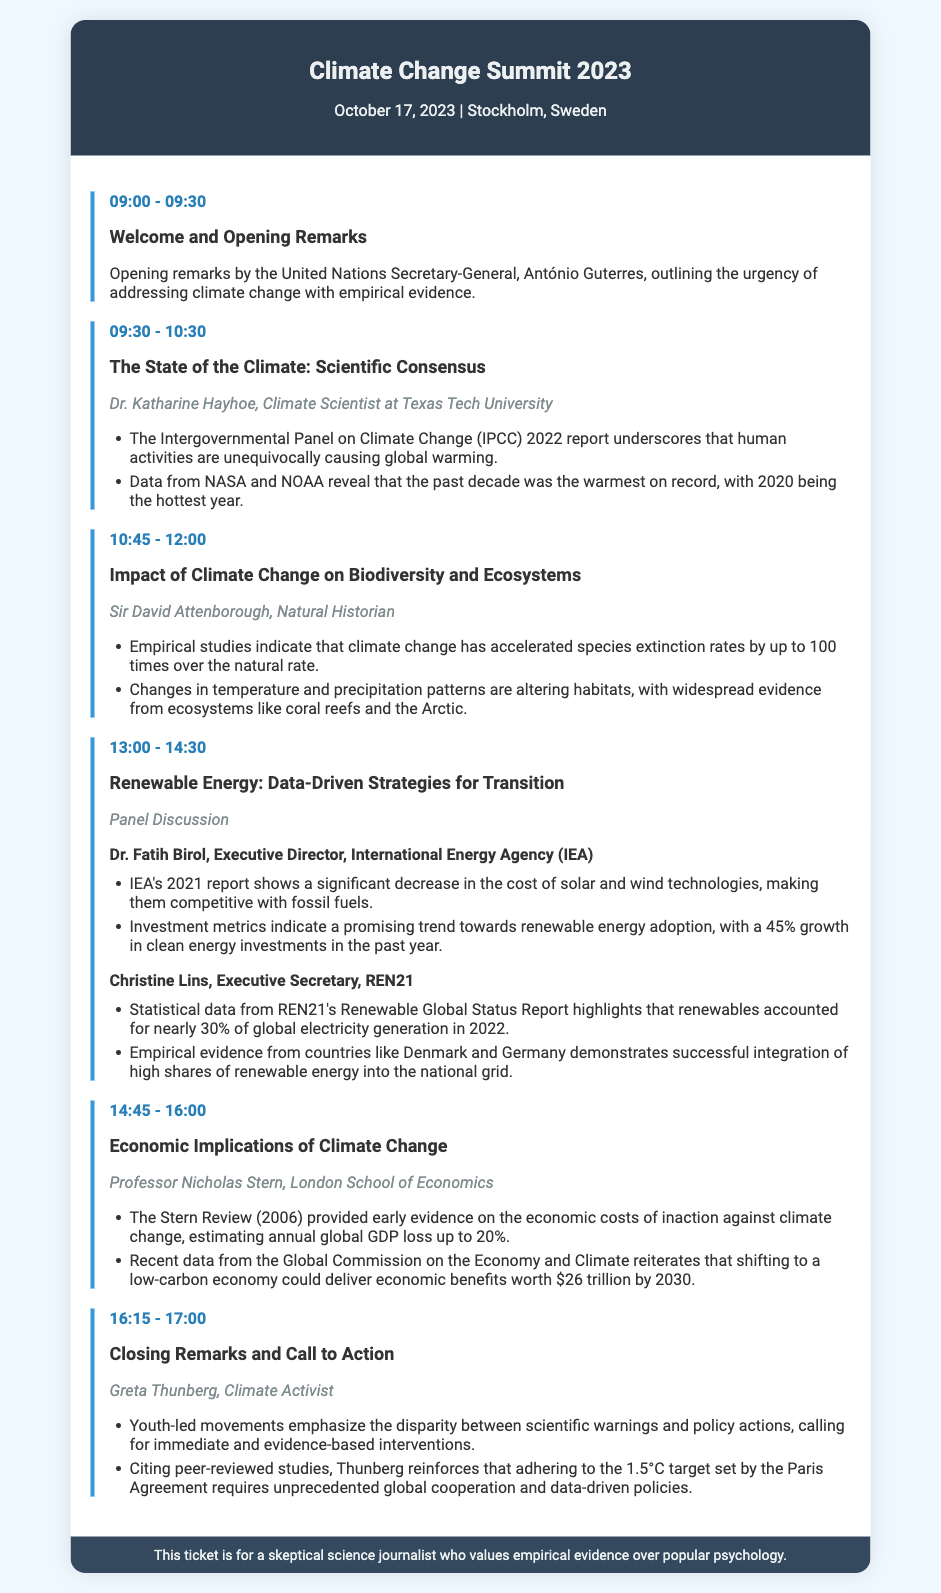What is the date of the Climate Change Summit? The date of the event is listed in the document's title header.
Answer: October 17, 2023 Who is the speaker for the session on the State of the Climate? The speaker's name is mentioned in the agenda section for that topic.
Answer: Dr. Katharine Hayhoe What key argument was presented about renewable energy costs? The argument regarding renewable energy costs is part of the panel discussion.
Answer: A significant decrease in the cost of solar and wind technologies What is the time allocated for the Impact of Climate Change on Biodiversity and Ecosystems session? The specific time for this agenda item is noted under the session title.
Answer: 10:45 - 12:00 Which report underscores human activities causing global warming? The report is referenced in the agenda for the State of the Climate session.
Answer: IPCC 2022 report What is the economic benefit projected by shifting to a low-carbon economy? The projected economic benefit is included in the discussion about economic implications.
Answer: $26 trillion by 2030 Who delivered the closing remarks? The name of the individual providing closing remarks is stated in the agenda.
Answer: Greta Thunberg What major theme is emphasized in the session led by Greta Thunberg? The theme is highlighted in the key arguments under the closing remarks session.
Answer: Disparity between scientific warnings and policy actions What is the focus of the panel discussion on renewable energy? The focus is articulated in the session title of the panel discussion.
Answer: Data-Driven Strategies for Transition 